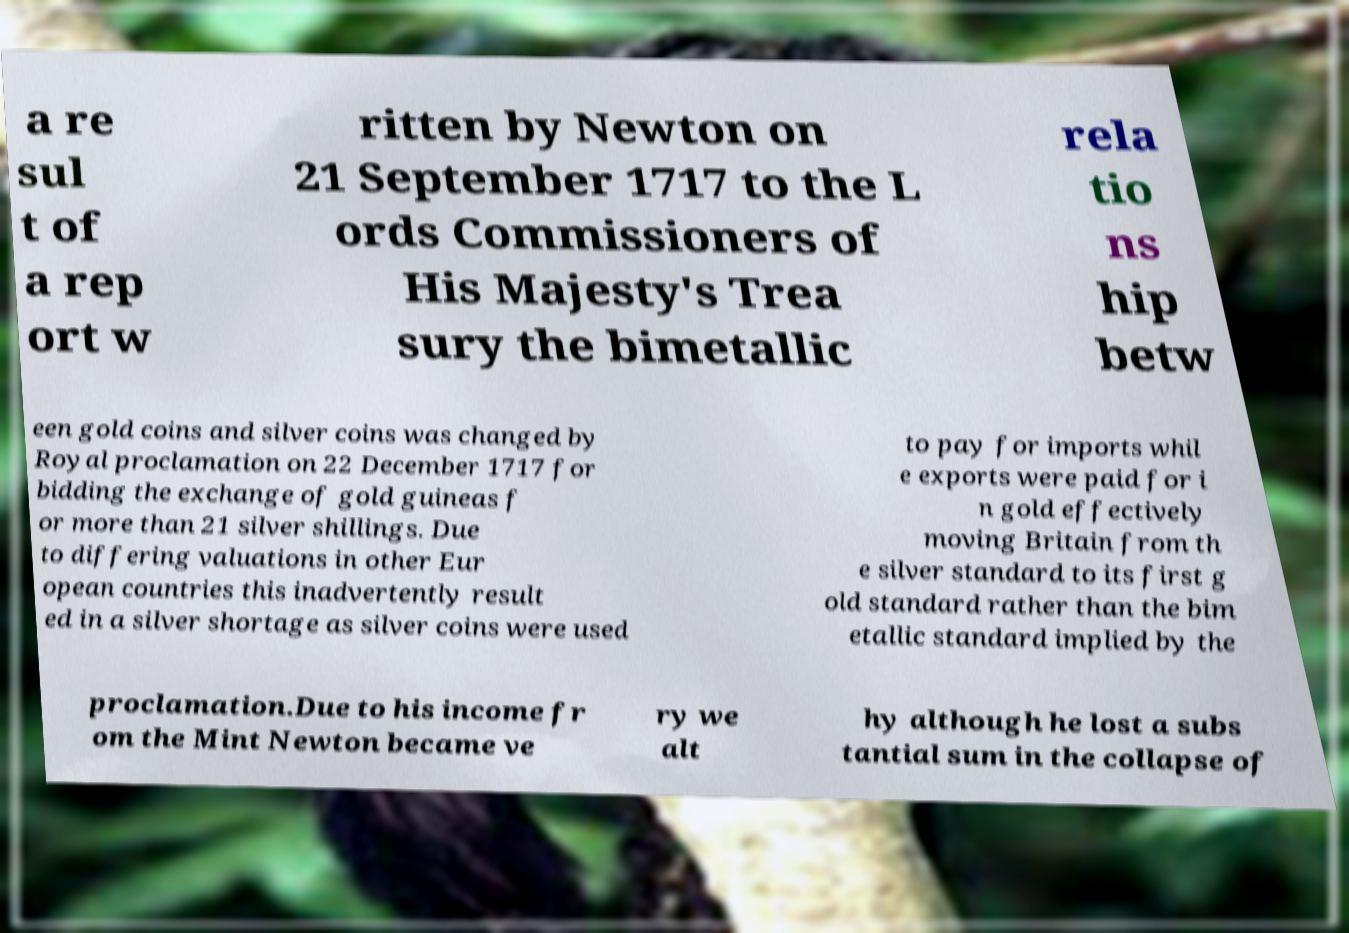I need the written content from this picture converted into text. Can you do that? a re sul t of a rep ort w ritten by Newton on 21 September 1717 to the L ords Commissioners of His Majesty's Trea sury the bimetallic rela tio ns hip betw een gold coins and silver coins was changed by Royal proclamation on 22 December 1717 for bidding the exchange of gold guineas f or more than 21 silver shillings. Due to differing valuations in other Eur opean countries this inadvertently result ed in a silver shortage as silver coins were used to pay for imports whil e exports were paid for i n gold effectively moving Britain from th e silver standard to its first g old standard rather than the bim etallic standard implied by the proclamation.Due to his income fr om the Mint Newton became ve ry we alt hy although he lost a subs tantial sum in the collapse of 